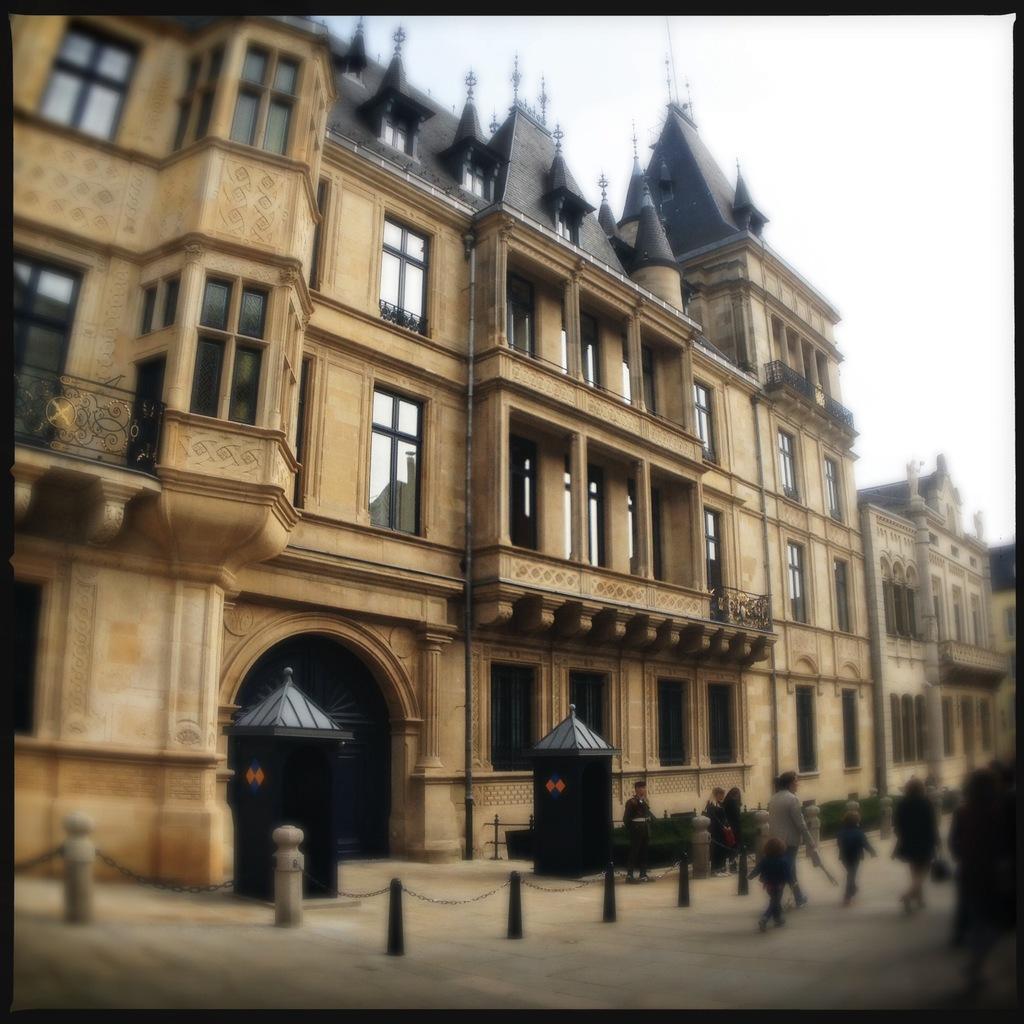Describe this image in one or two sentences. It is a building, in the right side few people are walking. 